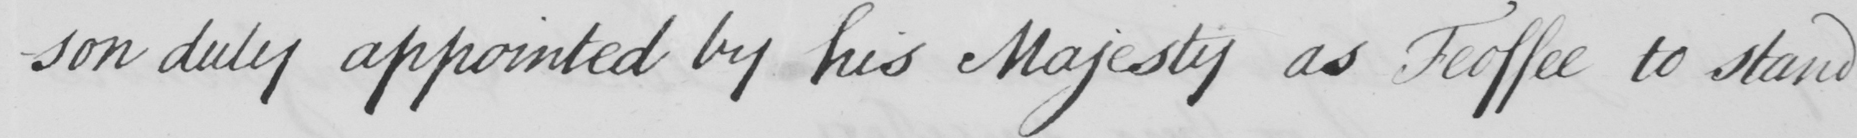Please provide the text content of this handwritten line. -son duly appointed by his Majesty as Feoffee to stand 